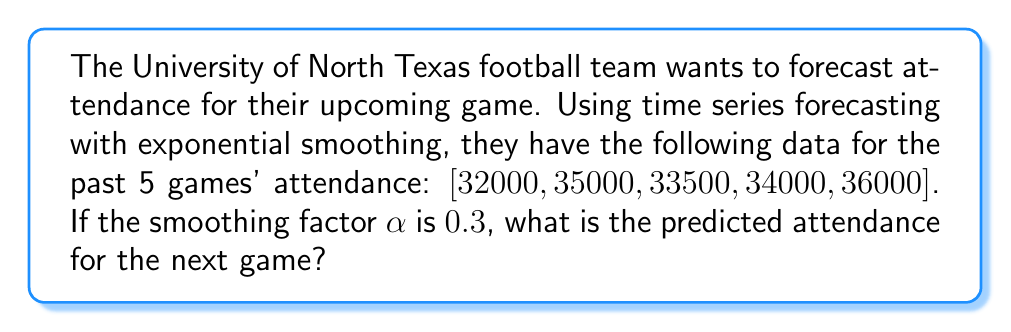What is the answer to this math problem? To solve this problem, we'll use the exponential smoothing formula for time series forecasting:

$$F_{t+1} = \alpha Y_t + (1-\alpha)F_t$$

Where:
$F_{t+1}$ is the forecast for the next period
$\alpha$ is the smoothing factor (0.3 in this case)
$Y_t$ is the actual value for the current period
$F_t$ is the forecast for the current period

Let's calculate step-by-step:

1) First, we need an initial forecast. We'll use the first actual value: 32000

2) Now, let's calculate each forecast:

   For game 2: $F_2 = 0.3(32000) + 0.7(32000) = 32000$
   
   For game 3: $F_3 = 0.3(35000) + 0.7(32000) = 32900$
   
   For game 4: $F_4 = 0.3(33500) + 0.7(32900) = 33080$
   
   For game 5: $F_5 = 0.3(34000) + 0.7(33080) = 33356$

3) Now, we can calculate the forecast for the next game:

   $F_6 = 0.3(36000) + 0.7(33356) = 34149.2$

4) Rounding to the nearest whole number (as we can't have fractional attendance):

   $F_6 \approx 34149$
Answer: 34149 